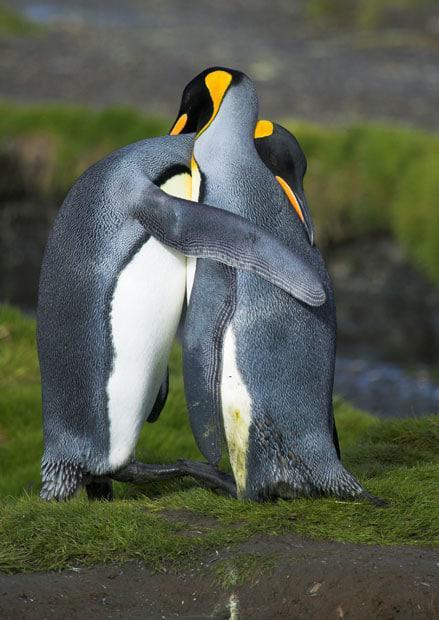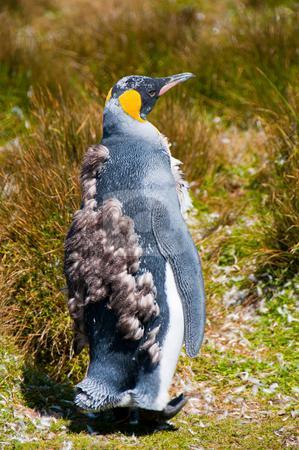The first image is the image on the left, the second image is the image on the right. Evaluate the accuracy of this statement regarding the images: "A sea lion is shown in one of the images.". Is it true? Answer yes or no. No. 